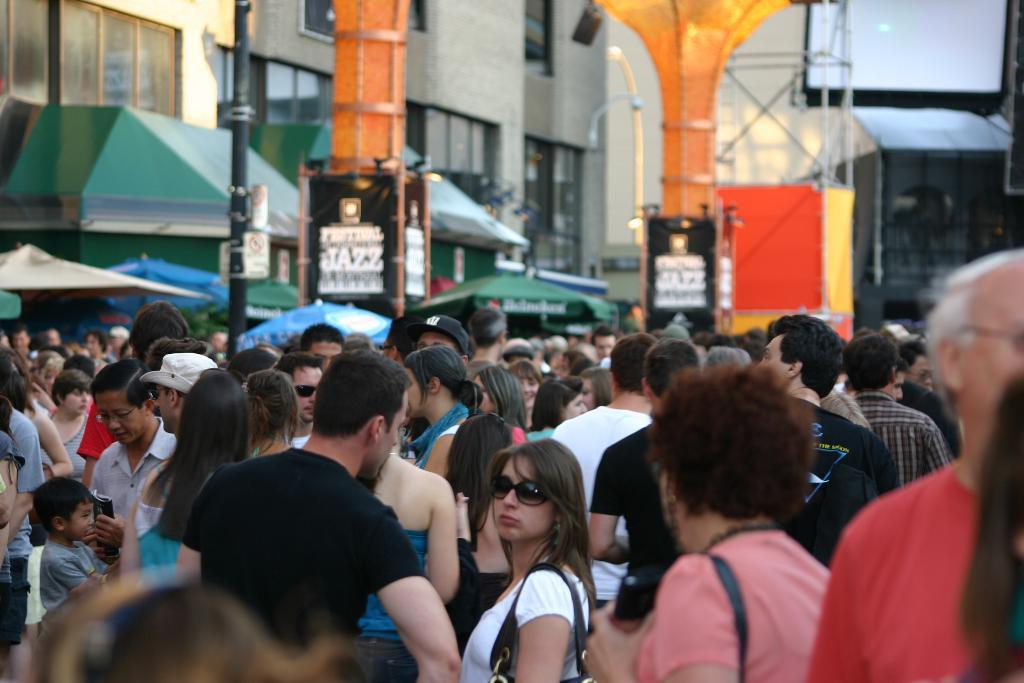What can be seen in the image in terms of human presence? There are people standing in the image. What type of structures are visible in the image? There are buildings in the image. What specific architectural feature can be observed in the image? There are orange color pillars in the image. What else is present in the image besides people and buildings? There are boards and tents in the image. Are there any fairies flying around the tents in the image? There is no mention of fairies in the image, so we cannot confirm their presence. What type of material is the crowd made of in the image? There is no crowd mentioned in the image, only individual people standing. 